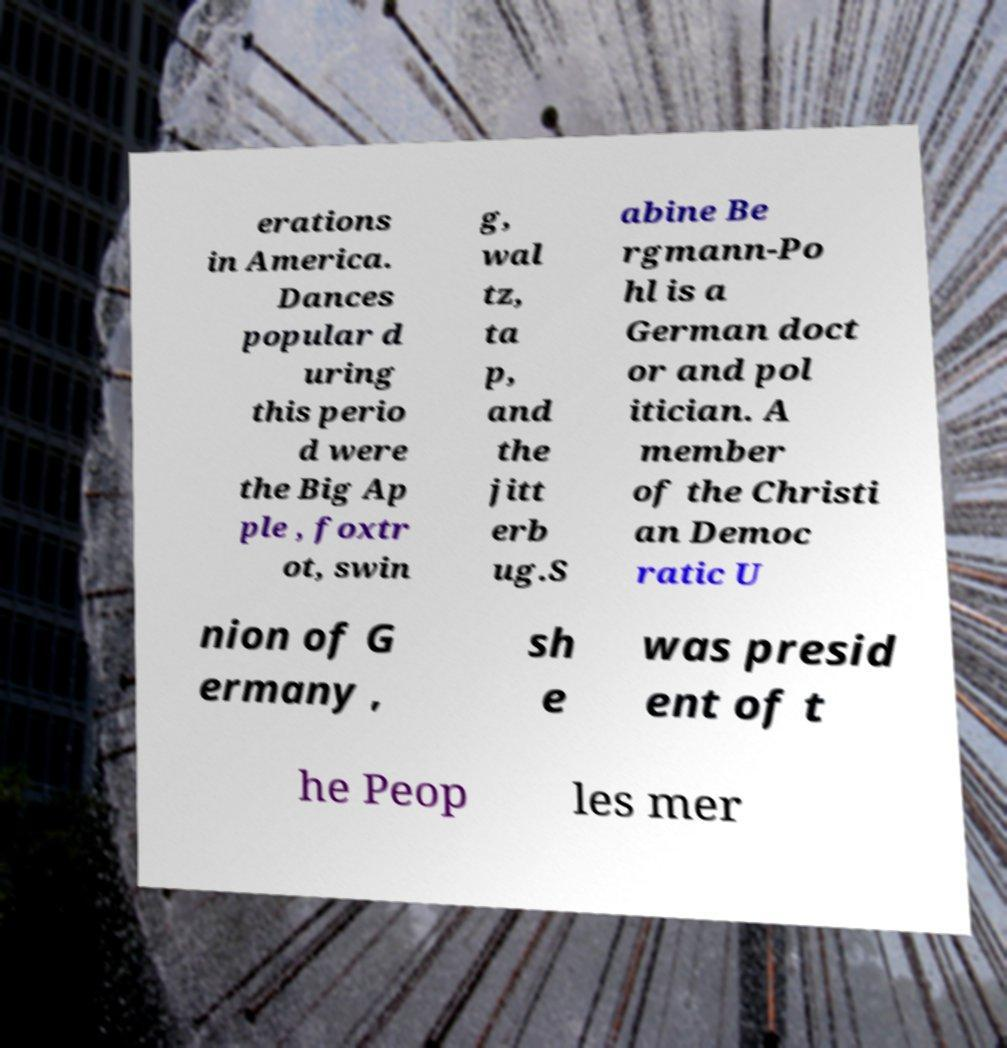Could you extract and type out the text from this image? erations in America. Dances popular d uring this perio d were the Big Ap ple , foxtr ot, swin g, wal tz, ta p, and the jitt erb ug.S abine Be rgmann-Po hl is a German doct or and pol itician. A member of the Christi an Democ ratic U nion of G ermany , sh e was presid ent of t he Peop les mer 